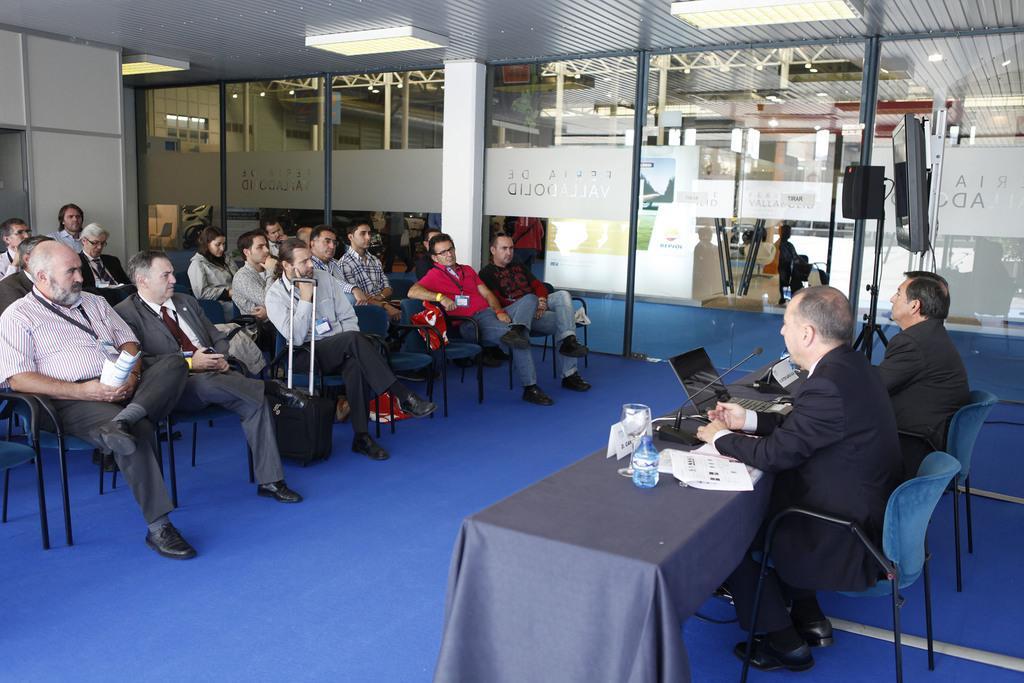How would you summarize this image in a sentence or two? A group of people sitting and listening. There are two men in the opposite side with a table. There is laptop,mic and glass on the table. There is TV screen beside the men. The room is illuminated with the lights on roof. 